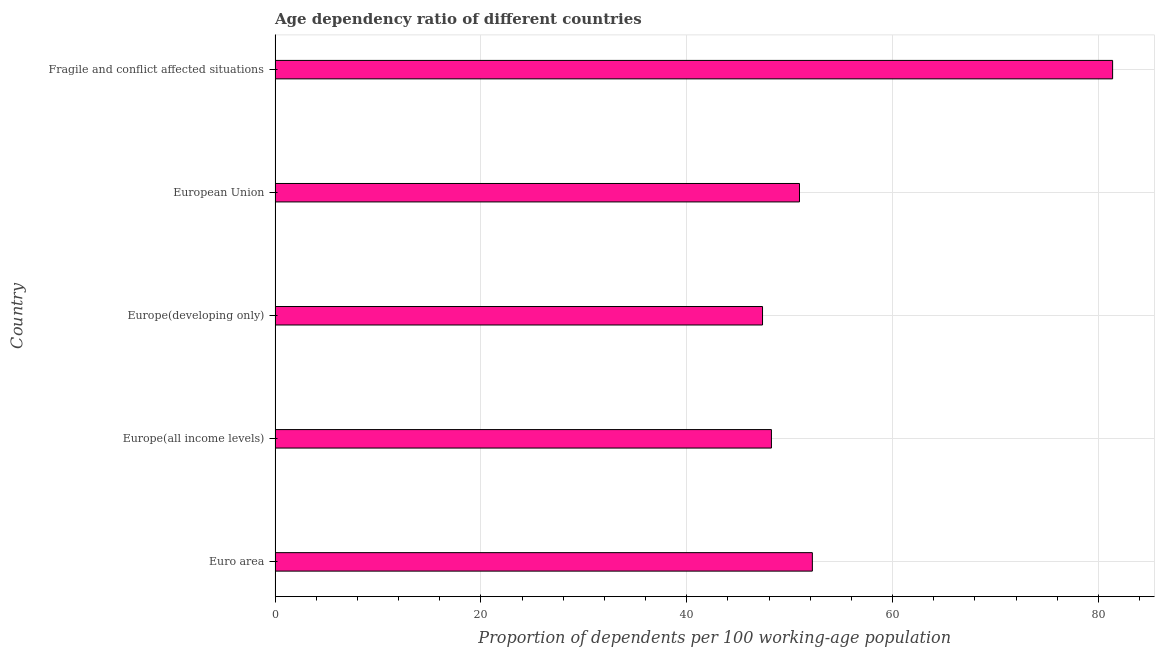Does the graph contain grids?
Provide a short and direct response. Yes. What is the title of the graph?
Provide a short and direct response. Age dependency ratio of different countries. What is the label or title of the X-axis?
Offer a terse response. Proportion of dependents per 100 working-age population. What is the label or title of the Y-axis?
Offer a terse response. Country. What is the age dependency ratio in Europe(developing only)?
Offer a terse response. 47.37. Across all countries, what is the maximum age dependency ratio?
Give a very brief answer. 81.39. Across all countries, what is the minimum age dependency ratio?
Keep it short and to the point. 47.37. In which country was the age dependency ratio maximum?
Your response must be concise. Fragile and conflict affected situations. In which country was the age dependency ratio minimum?
Your answer should be very brief. Europe(developing only). What is the sum of the age dependency ratio?
Keep it short and to the point. 280.15. What is the difference between the age dependency ratio in Euro area and Europe(developing only)?
Give a very brief answer. 4.84. What is the average age dependency ratio per country?
Ensure brevity in your answer.  56.03. What is the median age dependency ratio?
Offer a very short reply. 50.96. In how many countries, is the age dependency ratio greater than 60 ?
Offer a terse response. 1. What is the ratio of the age dependency ratio in Euro area to that in Europe(all income levels)?
Keep it short and to the point. 1.08. Is the age dependency ratio in Euro area less than that in Europe(developing only)?
Offer a terse response. No. What is the difference between the highest and the second highest age dependency ratio?
Your response must be concise. 29.18. Is the sum of the age dependency ratio in Europe(all income levels) and Europe(developing only) greater than the maximum age dependency ratio across all countries?
Keep it short and to the point. Yes. What is the difference between the highest and the lowest age dependency ratio?
Provide a short and direct response. 34.02. How many countries are there in the graph?
Ensure brevity in your answer.  5. What is the difference between two consecutive major ticks on the X-axis?
Your response must be concise. 20. What is the Proportion of dependents per 100 working-age population in Euro area?
Your answer should be very brief. 52.21. What is the Proportion of dependents per 100 working-age population in Europe(all income levels)?
Give a very brief answer. 48.23. What is the Proportion of dependents per 100 working-age population of Europe(developing only)?
Make the answer very short. 47.37. What is the Proportion of dependents per 100 working-age population in European Union?
Offer a terse response. 50.96. What is the Proportion of dependents per 100 working-age population in Fragile and conflict affected situations?
Make the answer very short. 81.39. What is the difference between the Proportion of dependents per 100 working-age population in Euro area and Europe(all income levels)?
Offer a terse response. 3.98. What is the difference between the Proportion of dependents per 100 working-age population in Euro area and Europe(developing only)?
Your response must be concise. 4.84. What is the difference between the Proportion of dependents per 100 working-age population in Euro area and European Union?
Make the answer very short. 1.25. What is the difference between the Proportion of dependents per 100 working-age population in Euro area and Fragile and conflict affected situations?
Your answer should be compact. -29.18. What is the difference between the Proportion of dependents per 100 working-age population in Europe(all income levels) and Europe(developing only)?
Ensure brevity in your answer.  0.86. What is the difference between the Proportion of dependents per 100 working-age population in Europe(all income levels) and European Union?
Your response must be concise. -2.73. What is the difference between the Proportion of dependents per 100 working-age population in Europe(all income levels) and Fragile and conflict affected situations?
Provide a succinct answer. -33.16. What is the difference between the Proportion of dependents per 100 working-age population in Europe(developing only) and European Union?
Offer a terse response. -3.59. What is the difference between the Proportion of dependents per 100 working-age population in Europe(developing only) and Fragile and conflict affected situations?
Your answer should be compact. -34.02. What is the difference between the Proportion of dependents per 100 working-age population in European Union and Fragile and conflict affected situations?
Give a very brief answer. -30.43. What is the ratio of the Proportion of dependents per 100 working-age population in Euro area to that in Europe(all income levels)?
Your answer should be compact. 1.08. What is the ratio of the Proportion of dependents per 100 working-age population in Euro area to that in Europe(developing only)?
Provide a short and direct response. 1.1. What is the ratio of the Proportion of dependents per 100 working-age population in Euro area to that in Fragile and conflict affected situations?
Provide a succinct answer. 0.64. What is the ratio of the Proportion of dependents per 100 working-age population in Europe(all income levels) to that in European Union?
Your answer should be compact. 0.95. What is the ratio of the Proportion of dependents per 100 working-age population in Europe(all income levels) to that in Fragile and conflict affected situations?
Give a very brief answer. 0.59. What is the ratio of the Proportion of dependents per 100 working-age population in Europe(developing only) to that in European Union?
Your answer should be very brief. 0.93. What is the ratio of the Proportion of dependents per 100 working-age population in Europe(developing only) to that in Fragile and conflict affected situations?
Offer a very short reply. 0.58. What is the ratio of the Proportion of dependents per 100 working-age population in European Union to that in Fragile and conflict affected situations?
Offer a very short reply. 0.63. 